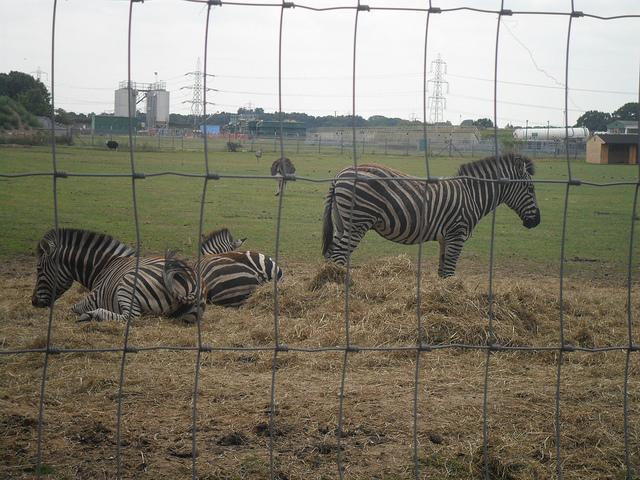How many animals are standing?
Give a very brief answer. 1. How many zebras are there?
Give a very brief answer. 3. 